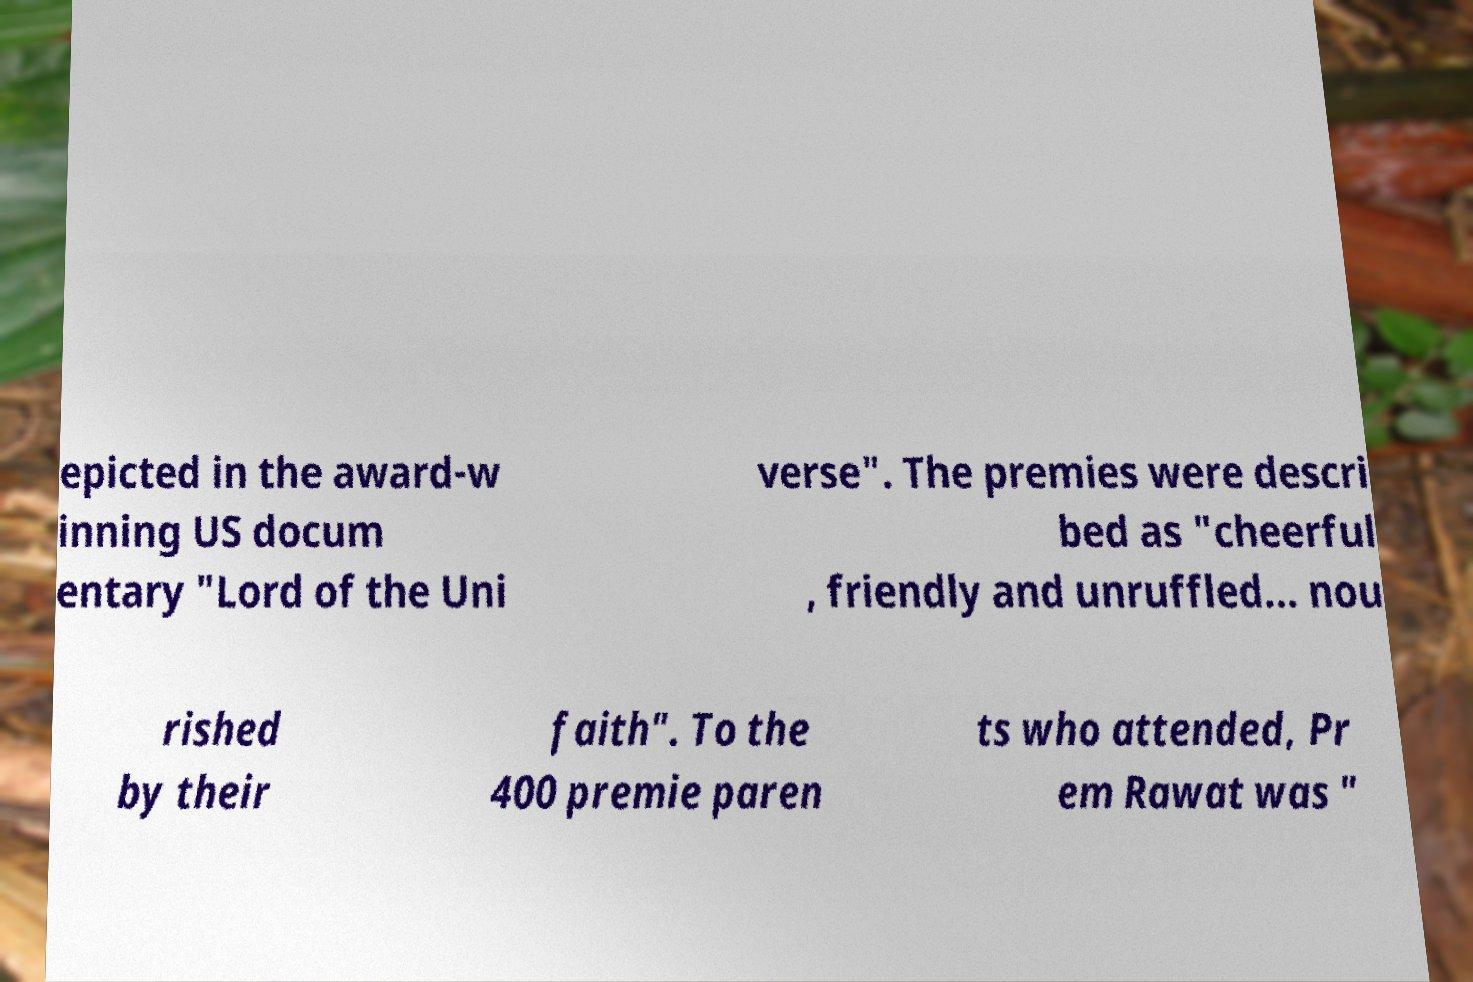There's text embedded in this image that I need extracted. Can you transcribe it verbatim? epicted in the award-w inning US docum entary "Lord of the Uni verse". The premies were descri bed as "cheerful , friendly and unruffled... nou rished by their faith". To the 400 premie paren ts who attended, Pr em Rawat was " 